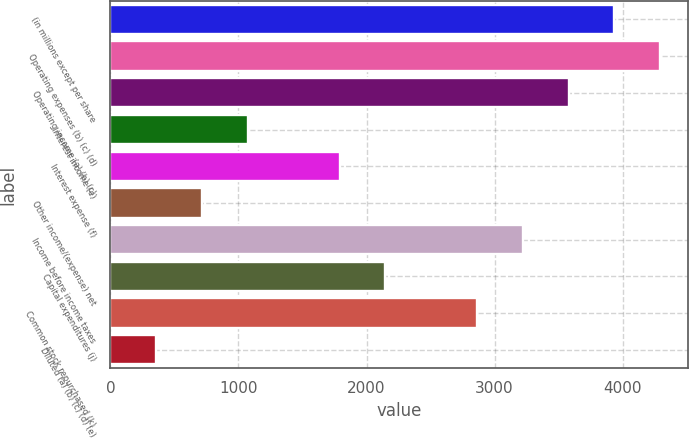Convert chart. <chart><loc_0><loc_0><loc_500><loc_500><bar_chart><fcel>(in millions except per share<fcel>Operating expenses (b) (c) (d)<fcel>Operating income (a) (b) (c)<fcel>Interest income (e)<fcel>Interest expense (f)<fcel>Other income/(expense) net<fcel>Income before income taxes<fcel>Capital expenditures (j)<fcel>Common stock repurchased (k)<fcel>Diluted (a) (b) (c) (d) (e)<nl><fcel>3936.06<fcel>4293.88<fcel>3578.24<fcel>1073.5<fcel>1789.14<fcel>715.68<fcel>3220.42<fcel>2146.96<fcel>2862.6<fcel>357.86<nl></chart> 